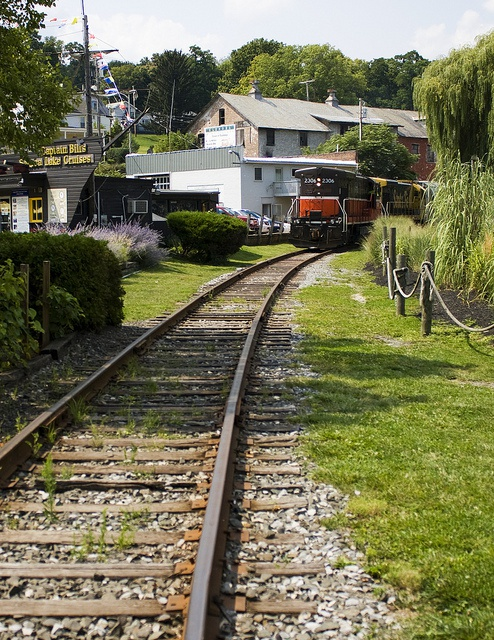Describe the objects in this image and their specific colors. I can see train in black, maroon, gray, and darkgray tones, car in black, gray, darkgray, and maroon tones, car in black, gray, lightgray, and darkgray tones, and car in black, lightgray, darkgray, and gray tones in this image. 